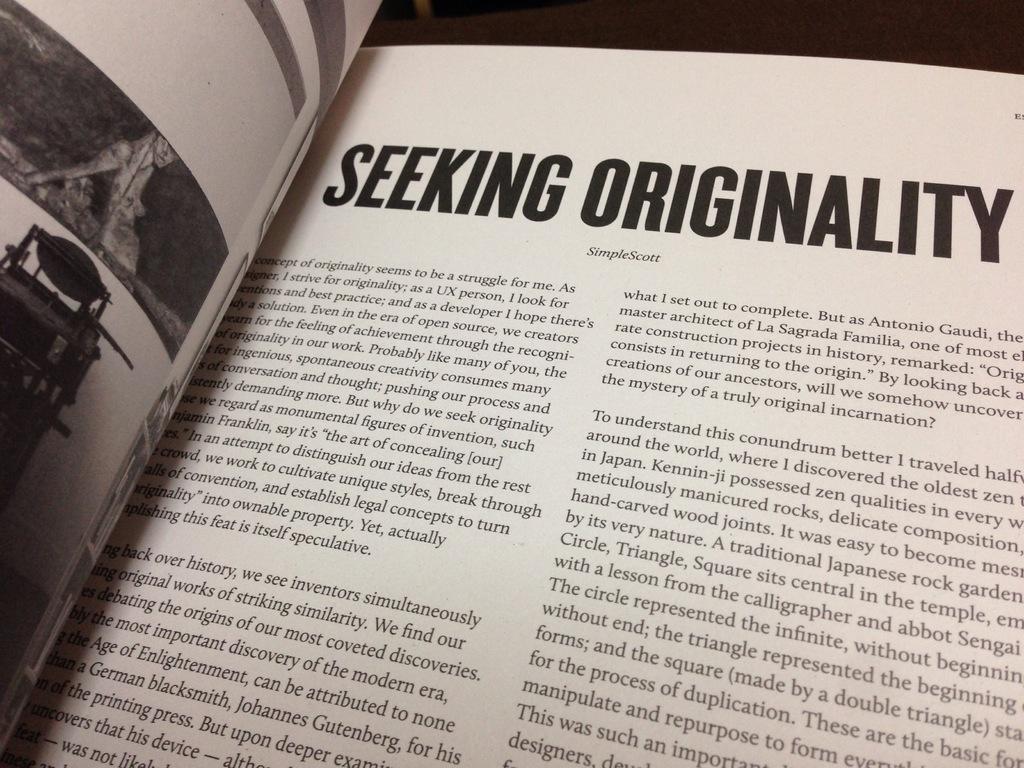Who is the author?
Give a very brief answer. Simplescott. 